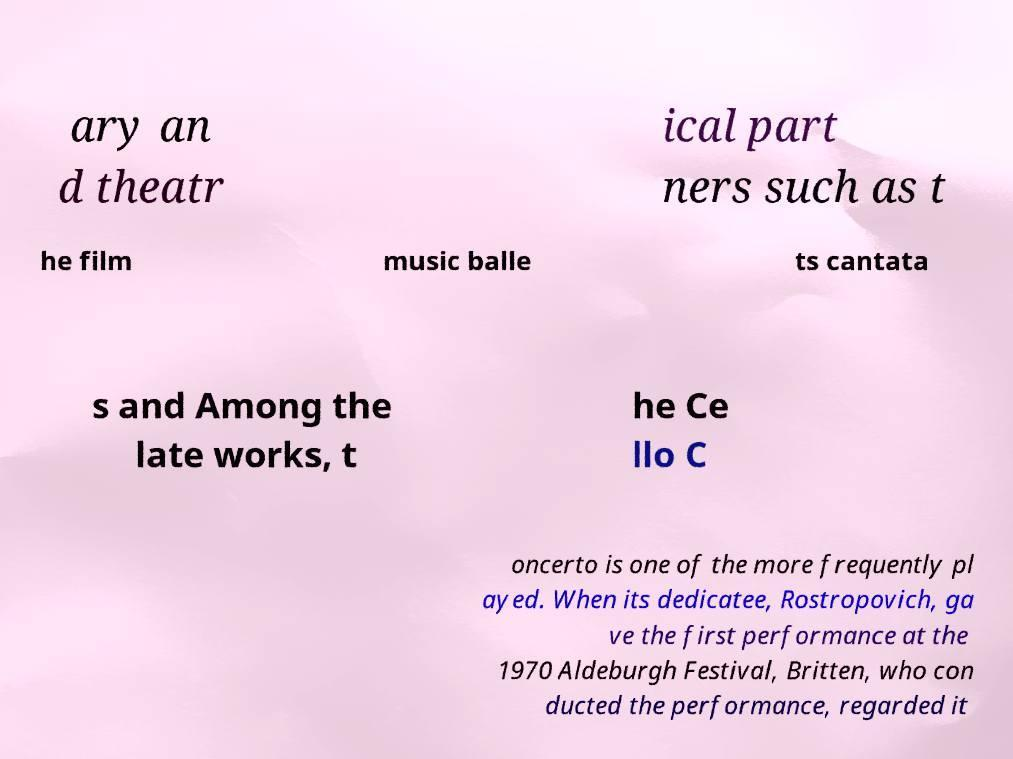For documentation purposes, I need the text within this image transcribed. Could you provide that? ary an d theatr ical part ners such as t he film music balle ts cantata s and Among the late works, t he Ce llo C oncerto is one of the more frequently pl ayed. When its dedicatee, Rostropovich, ga ve the first performance at the 1970 Aldeburgh Festival, Britten, who con ducted the performance, regarded it 